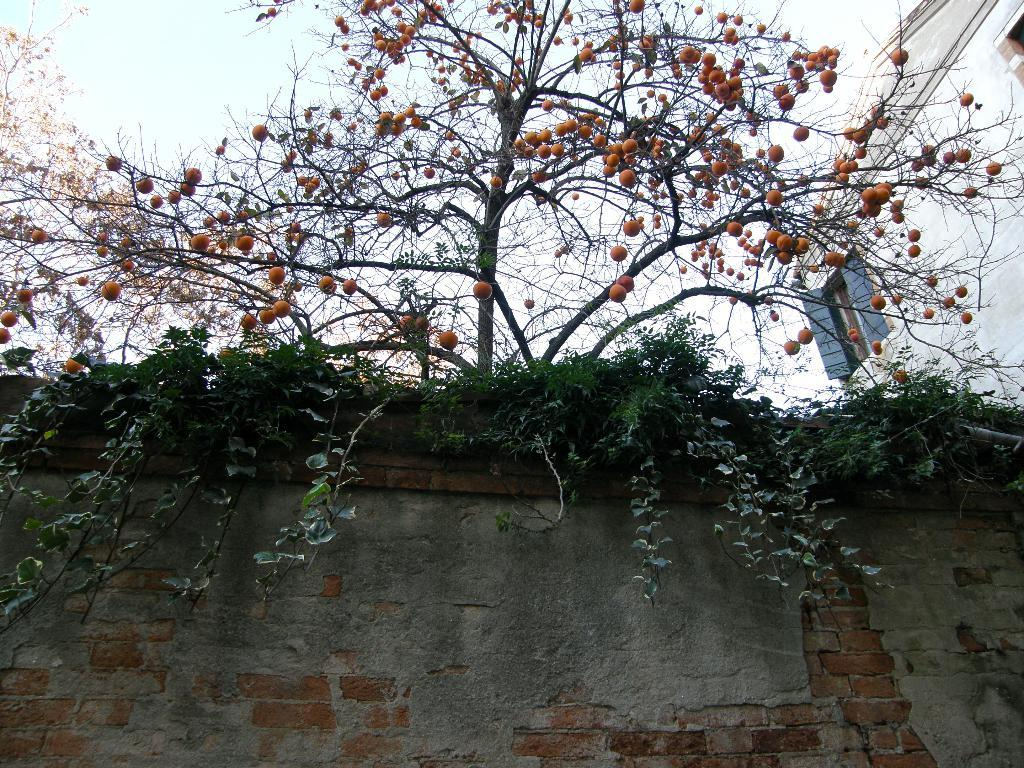What type of plant is present in the image with fruits? There is a tree with fruits in the image. What other type of plant can be seen in the image? There are creepers in the image. What structures are visible in the image? There are walls and a building in the image. What architectural features can be seen in the building? There are windows in the image. What is visible in the sky in the image? The sky is visible in the image, and there are clouds in the sky. What type of tent can be seen in the image? There is no tent present in the image. What emotion is the tree feeling in the image? Trees do not have emotions, so this question cannot be answered. 